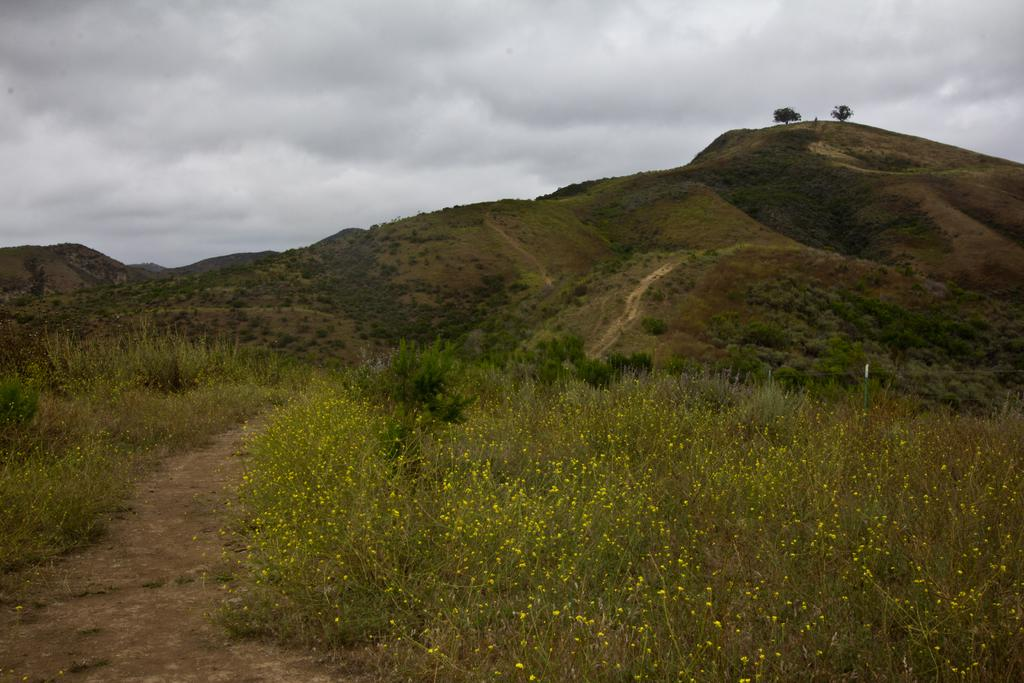What type of landscape feature can be seen in the image? There are hills in the image. What type of vegetation is present in the image? There are trees and plants in the image. What can be seen in the background of the image? The sky is visible in the background of the image. How many houses can be seen in the image? There are no houses present in the image; it features hills, trees, plants, and the sky. Are there any horses visible in the image? There are no horses present in the image. 